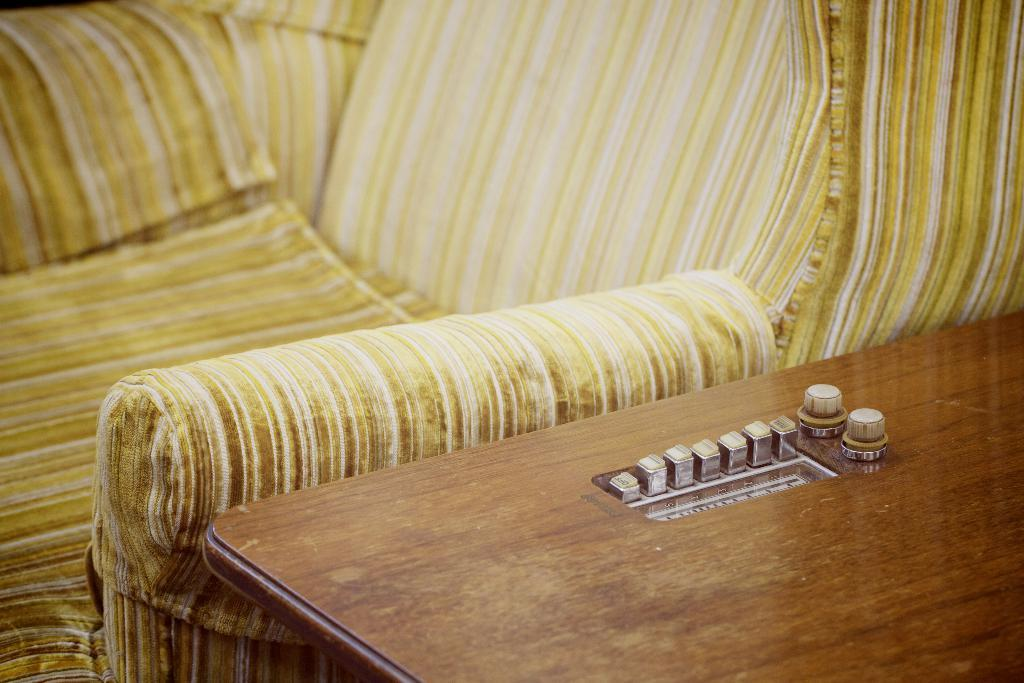What objects are on the wooden table in the image? There are buttons on the wooden table in the image. What type of furniture is located near the wooden table? There is a sofa beside the wooden table in the image. How many boys are playing the drum in the image? There are no boys or drums present in the image. 